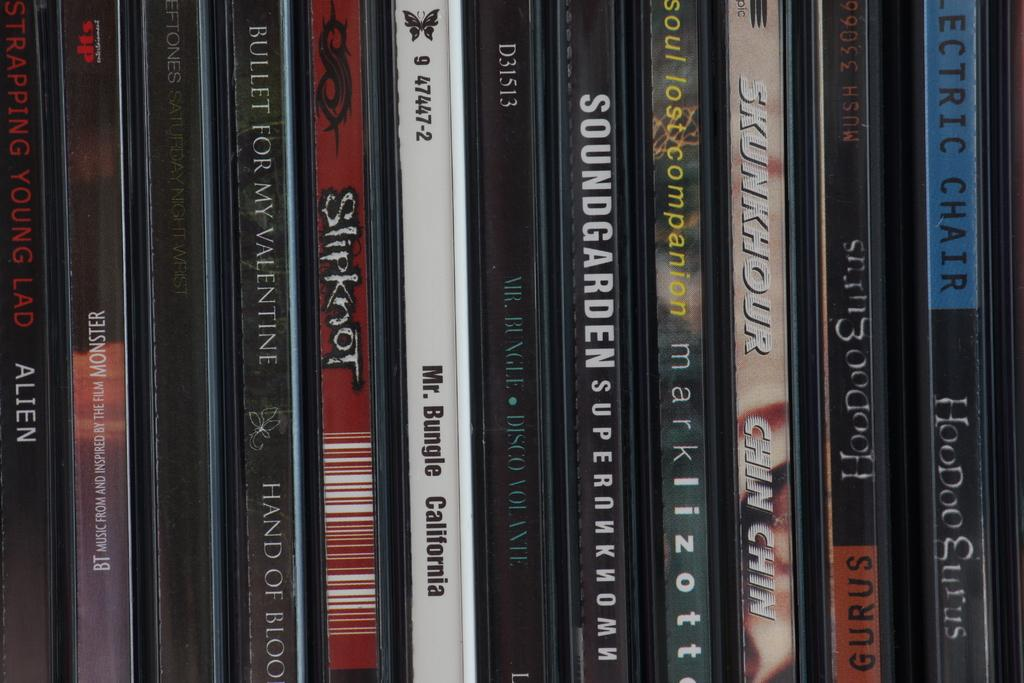<image>
Share a concise interpretation of the image provided. A selection of CDs, including Mr Bungle's California. 